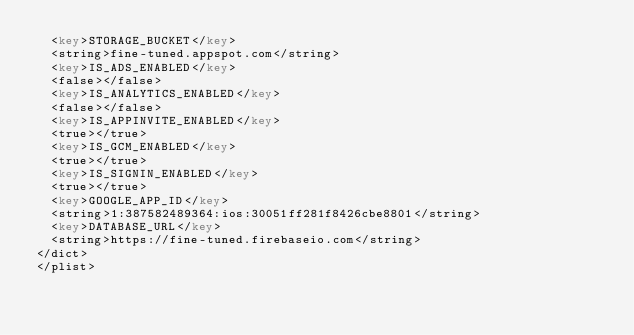Convert code to text. <code><loc_0><loc_0><loc_500><loc_500><_XML_>	<key>STORAGE_BUCKET</key>
	<string>fine-tuned.appspot.com</string>
	<key>IS_ADS_ENABLED</key>
	<false></false>
	<key>IS_ANALYTICS_ENABLED</key>
	<false></false>
	<key>IS_APPINVITE_ENABLED</key>
	<true></true>
	<key>IS_GCM_ENABLED</key>
	<true></true>
	<key>IS_SIGNIN_ENABLED</key>
	<true></true>
	<key>GOOGLE_APP_ID</key>
	<string>1:387582489364:ios:30051ff281f8426cbe8801</string>
	<key>DATABASE_URL</key>
	<string>https://fine-tuned.firebaseio.com</string>
</dict>
</plist></code> 